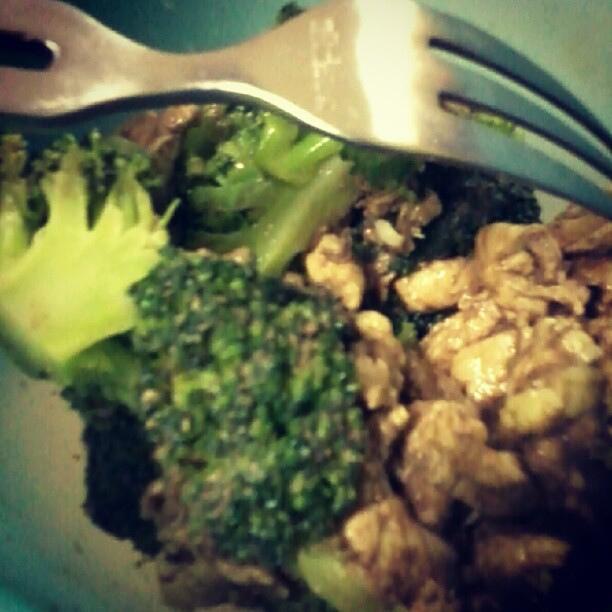How many sails does the boat have?
Give a very brief answer. 0. 